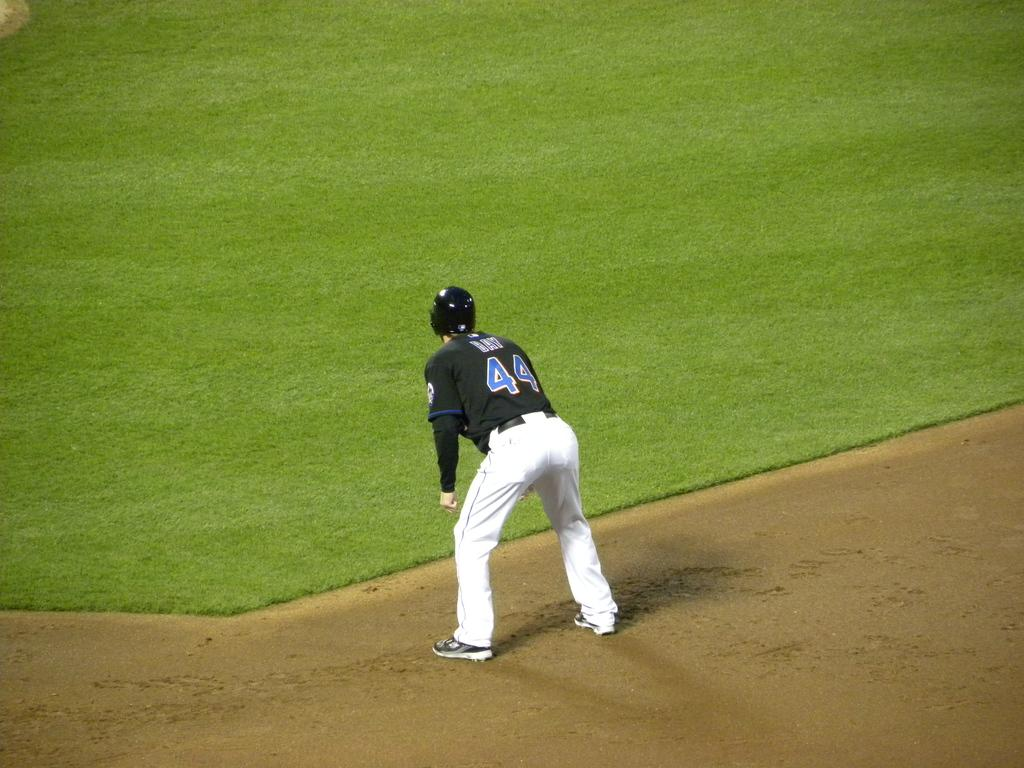<image>
Describe the image concisely. The baseball player is wearing the jersey number 44. 